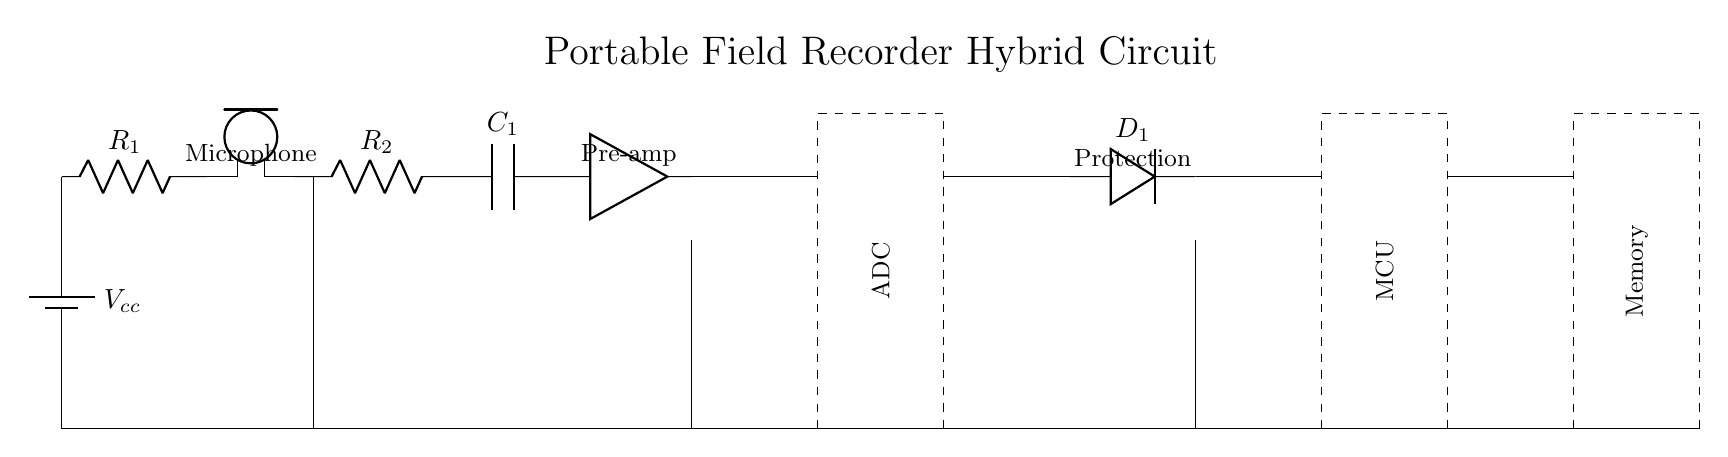what is the voltage source in this circuit? The voltage source is labeled as $V_{cc}$ and is the first component in the circuit. It provides the necessary power to the circuit.
Answer: Vcc how many resistors are in the circuit? There are two resistors labeled as $R_1$ and $R_2$. They serve to limit current and drop voltage at specific points in the circuit.
Answer: 2 what component converts analog signals to digital? The component that converts analog signals to digital is labeled as ADC, and it takes the input from the microphone and processes it into a digital format for further use.
Answer: ADC what is the function of the pre-amplifier in this circuit? The pre-amplifier, commonly indicated as the "amp," boosts the signal from the microphone to a usable level for the ADC. It amplifies weak sound signals to ensure they are strong enough for conversion.
Answer: Signal amplification which component protects the circuit? The protection component is labeled as $D_1$, which indicates a diode used for safeguarding the circuit from voltage spikes and ensuring current flows in one direction.
Answer: D1 how is the ground connected in this circuit? The ground connection spans from the bottom of the voltage source down to the end of the circuit, providing a common reference point for all components. Ground is connected to multiple points, including the microphone and other components.
Answer: Common ground what is the purpose of the memory component in this circuit? The memory component, labeled as "Memory," is responsible for storing the digital data processed by the MCU for later retrieval, ensuring that recorded audio can be accessed after recording.
Answer: Data storage 